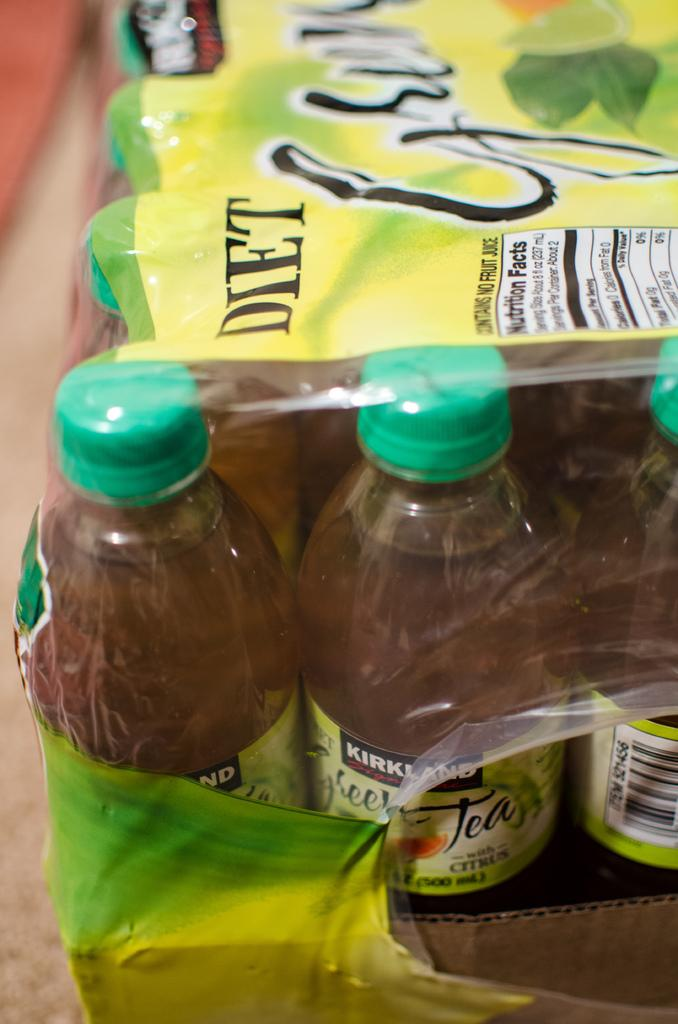<image>
Create a compact narrative representing the image presented. A package of tea that has a label on it that says Kirkland 